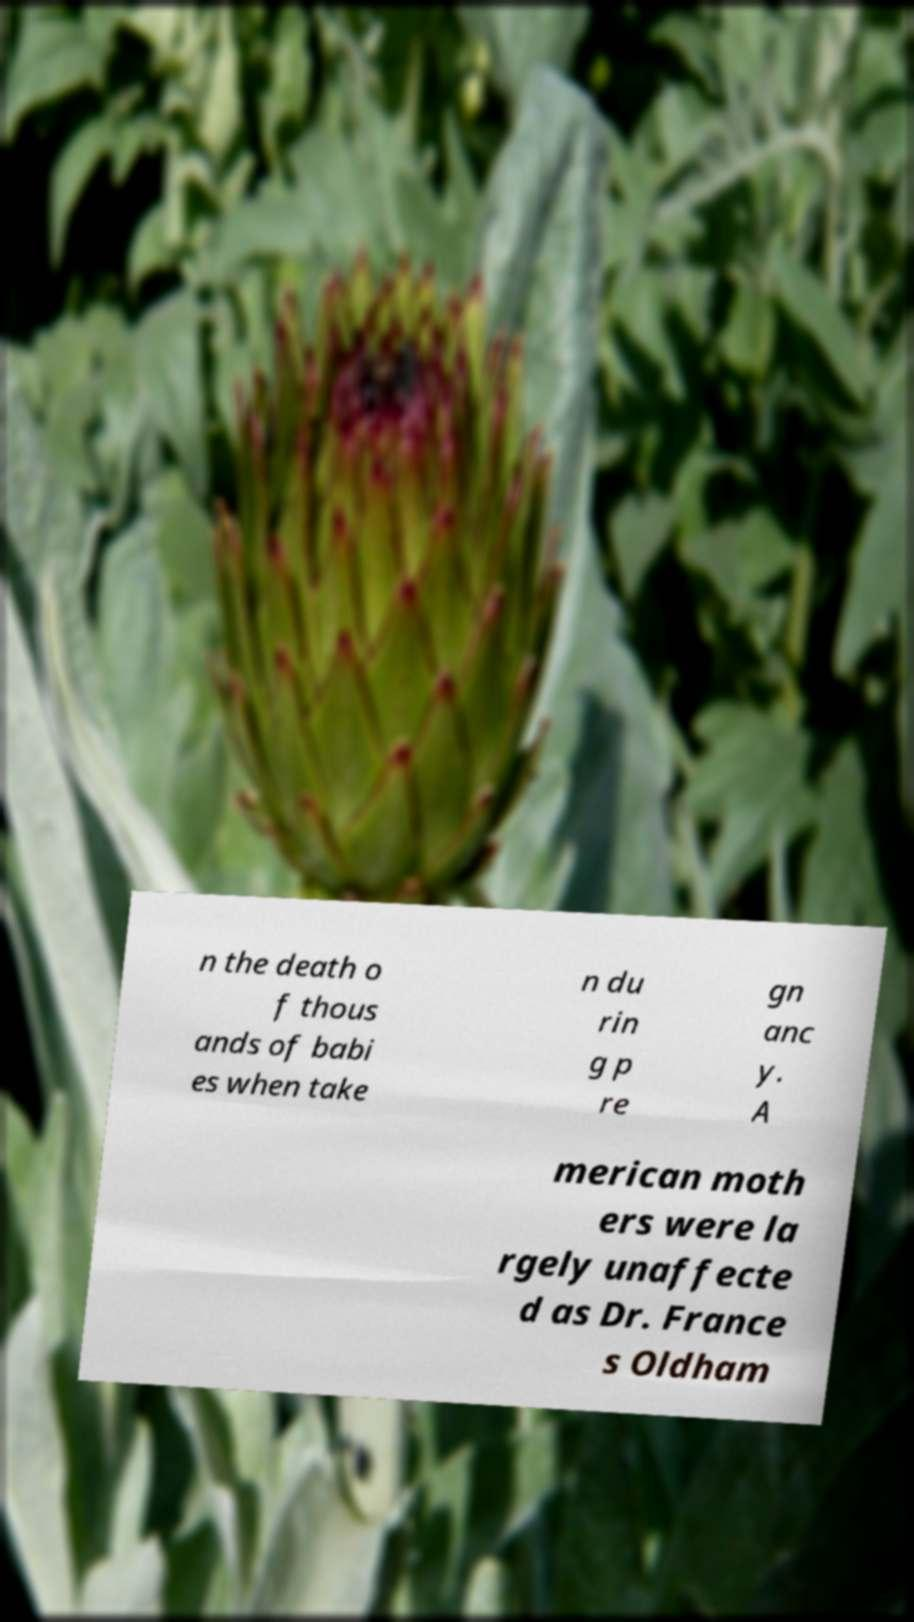I need the written content from this picture converted into text. Can you do that? n the death o f thous ands of babi es when take n du rin g p re gn anc y. A merican moth ers were la rgely unaffecte d as Dr. France s Oldham 